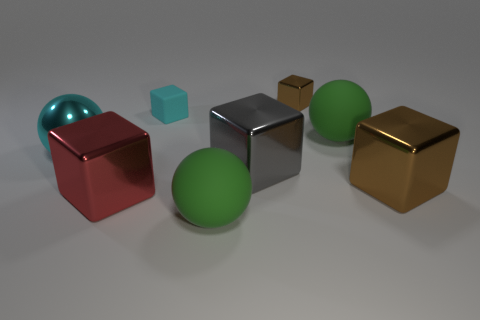Add 2 red metal things. How many objects exist? 10 Subtract all shiny cubes. How many cubes are left? 1 Subtract all green spheres. How many brown blocks are left? 2 Subtract all cyan balls. How many balls are left? 2 Subtract all yellow balls. Subtract all gray cubes. How many balls are left? 3 Subtract 0 red balls. How many objects are left? 8 Subtract all spheres. How many objects are left? 5 Subtract 4 blocks. How many blocks are left? 1 Subtract all big red metallic objects. Subtract all small cyan blocks. How many objects are left? 6 Add 8 big red things. How many big red things are left? 9 